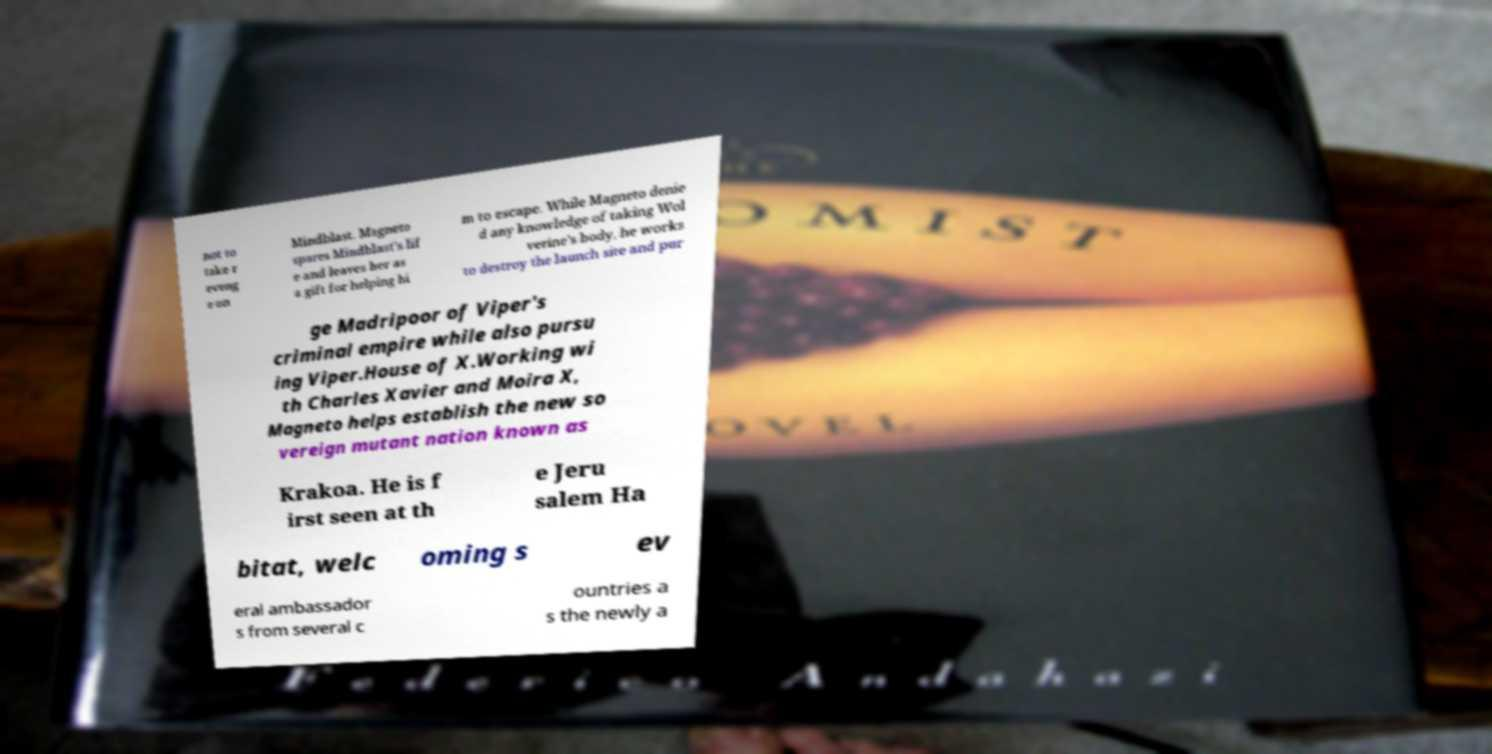For documentation purposes, I need the text within this image transcribed. Could you provide that? not to take r eveng e on Mindblast. Magneto spares Mindblast's lif e and leaves her as a gift for helping hi m to escape. While Magneto denie d any knowledge of taking Wol verine's body, he works to destroy the launch site and pur ge Madripoor of Viper's criminal empire while also pursu ing Viper.House of X.Working wi th Charles Xavier and Moira X, Magneto helps establish the new so vereign mutant nation known as Krakoa. He is f irst seen at th e Jeru salem Ha bitat, welc oming s ev eral ambassador s from several c ountries a s the newly a 